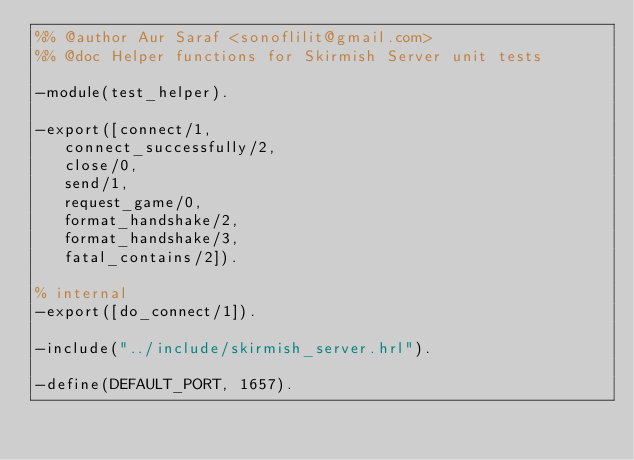Convert code to text. <code><loc_0><loc_0><loc_500><loc_500><_Erlang_>%% @author Aur Saraf <sonoflilit@gmail.com>
%% @doc Helper functions for Skirmish Server unit tests

-module(test_helper).

-export([connect/1,
	 connect_successfully/2,
	 close/0,
	 send/1,
	 request_game/0,
	 format_handshake/2,
	 format_handshake/3,
	 fatal_contains/2]).

% internal
-export([do_connect/1]).

-include("../include/skirmish_server.hrl").

-define(DEFAULT_PORT, 1657).
</code> 